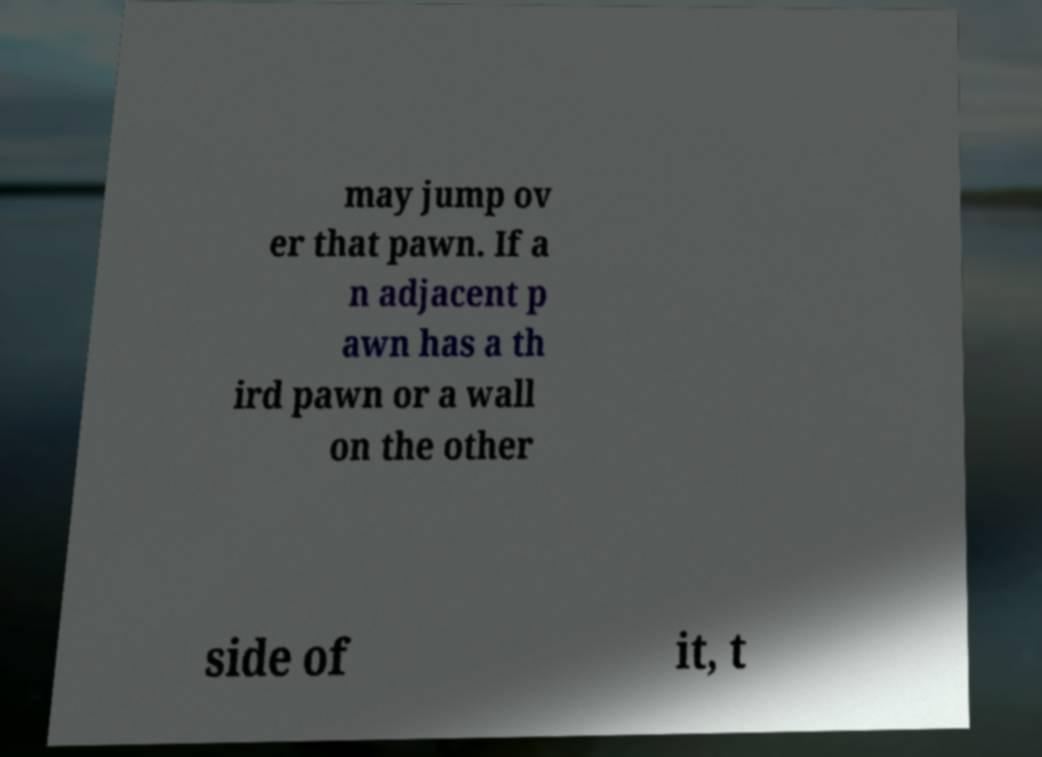For documentation purposes, I need the text within this image transcribed. Could you provide that? may jump ov er that pawn. If a n adjacent p awn has a th ird pawn or a wall on the other side of it, t 